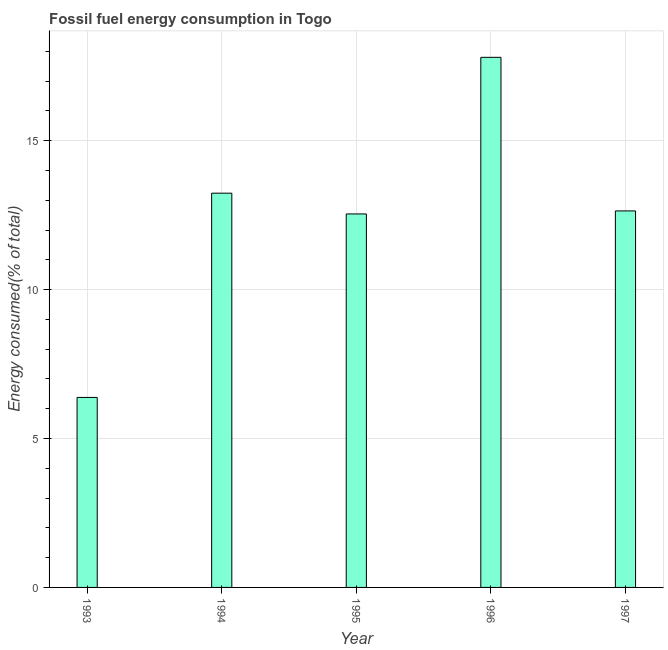Does the graph contain any zero values?
Offer a terse response. No. Does the graph contain grids?
Keep it short and to the point. Yes. What is the title of the graph?
Give a very brief answer. Fossil fuel energy consumption in Togo. What is the label or title of the Y-axis?
Provide a succinct answer. Energy consumed(% of total). What is the fossil fuel energy consumption in 1994?
Make the answer very short. 13.24. Across all years, what is the maximum fossil fuel energy consumption?
Your answer should be very brief. 17.8. Across all years, what is the minimum fossil fuel energy consumption?
Provide a succinct answer. 6.38. In which year was the fossil fuel energy consumption maximum?
Your answer should be compact. 1996. In which year was the fossil fuel energy consumption minimum?
Your answer should be compact. 1993. What is the sum of the fossil fuel energy consumption?
Offer a terse response. 62.6. What is the difference between the fossil fuel energy consumption in 1994 and 1995?
Give a very brief answer. 0.7. What is the average fossil fuel energy consumption per year?
Your answer should be very brief. 12.52. What is the median fossil fuel energy consumption?
Your answer should be very brief. 12.64. Do a majority of the years between 1995 and 1996 (inclusive) have fossil fuel energy consumption greater than 15 %?
Keep it short and to the point. No. What is the ratio of the fossil fuel energy consumption in 1995 to that in 1996?
Ensure brevity in your answer.  0.7. Is the fossil fuel energy consumption in 1995 less than that in 1996?
Offer a terse response. Yes. Is the difference between the fossil fuel energy consumption in 1995 and 1997 greater than the difference between any two years?
Give a very brief answer. No. What is the difference between the highest and the second highest fossil fuel energy consumption?
Offer a terse response. 4.56. Is the sum of the fossil fuel energy consumption in 1995 and 1996 greater than the maximum fossil fuel energy consumption across all years?
Your answer should be compact. Yes. What is the difference between the highest and the lowest fossil fuel energy consumption?
Make the answer very short. 11.42. In how many years, is the fossil fuel energy consumption greater than the average fossil fuel energy consumption taken over all years?
Keep it short and to the point. 4. How many bars are there?
Give a very brief answer. 5. Are all the bars in the graph horizontal?
Your response must be concise. No. How many years are there in the graph?
Your answer should be compact. 5. What is the difference between two consecutive major ticks on the Y-axis?
Your answer should be compact. 5. What is the Energy consumed(% of total) of 1993?
Provide a succinct answer. 6.38. What is the Energy consumed(% of total) in 1994?
Your answer should be very brief. 13.24. What is the Energy consumed(% of total) of 1995?
Offer a very short reply. 12.54. What is the Energy consumed(% of total) of 1996?
Make the answer very short. 17.8. What is the Energy consumed(% of total) in 1997?
Offer a terse response. 12.64. What is the difference between the Energy consumed(% of total) in 1993 and 1994?
Give a very brief answer. -6.86. What is the difference between the Energy consumed(% of total) in 1993 and 1995?
Give a very brief answer. -6.16. What is the difference between the Energy consumed(% of total) in 1993 and 1996?
Ensure brevity in your answer.  -11.42. What is the difference between the Energy consumed(% of total) in 1993 and 1997?
Your answer should be compact. -6.26. What is the difference between the Energy consumed(% of total) in 1994 and 1995?
Provide a short and direct response. 0.7. What is the difference between the Energy consumed(% of total) in 1994 and 1996?
Offer a very short reply. -4.56. What is the difference between the Energy consumed(% of total) in 1994 and 1997?
Give a very brief answer. 0.6. What is the difference between the Energy consumed(% of total) in 1995 and 1996?
Provide a short and direct response. -5.26. What is the difference between the Energy consumed(% of total) in 1995 and 1997?
Your answer should be very brief. -0.1. What is the difference between the Energy consumed(% of total) in 1996 and 1997?
Your answer should be compact. 5.16. What is the ratio of the Energy consumed(% of total) in 1993 to that in 1994?
Give a very brief answer. 0.48. What is the ratio of the Energy consumed(% of total) in 1993 to that in 1995?
Provide a succinct answer. 0.51. What is the ratio of the Energy consumed(% of total) in 1993 to that in 1996?
Offer a terse response. 0.36. What is the ratio of the Energy consumed(% of total) in 1993 to that in 1997?
Keep it short and to the point. 0.51. What is the ratio of the Energy consumed(% of total) in 1994 to that in 1995?
Ensure brevity in your answer.  1.06. What is the ratio of the Energy consumed(% of total) in 1994 to that in 1996?
Offer a very short reply. 0.74. What is the ratio of the Energy consumed(% of total) in 1994 to that in 1997?
Your response must be concise. 1.05. What is the ratio of the Energy consumed(% of total) in 1995 to that in 1996?
Provide a short and direct response. 0.7. What is the ratio of the Energy consumed(% of total) in 1996 to that in 1997?
Give a very brief answer. 1.41. 